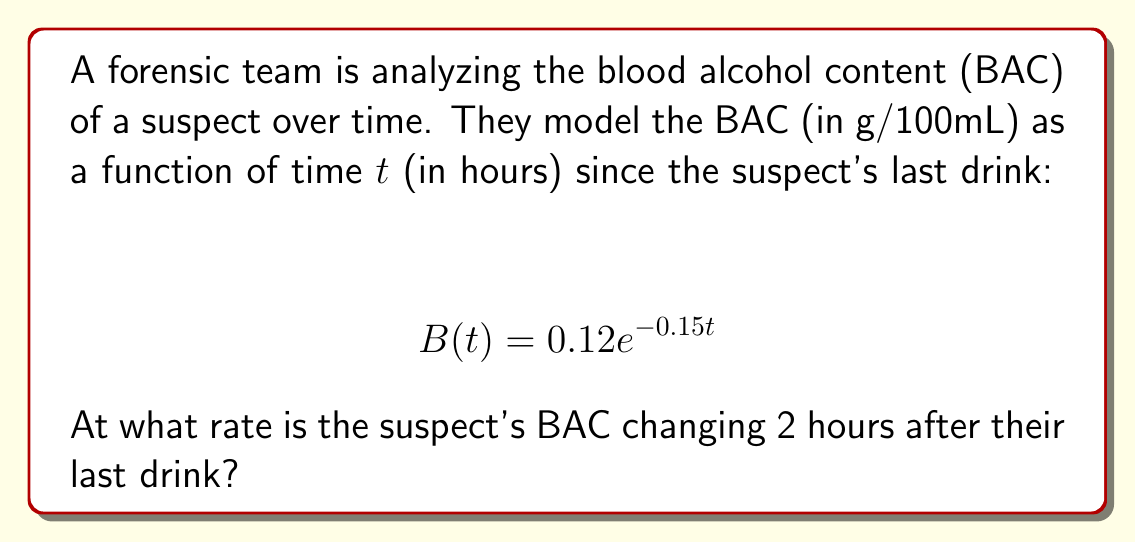What is the answer to this math problem? To solve this problem, we need to follow these steps:

1) The rate of change of BAC with respect to time is given by the derivative of B(t).

2) Let's find the derivative of B(t) using the chain rule:

   $$ \frac{dB}{dt} = 0.12 \cdot (-0.15) \cdot e^{-0.15t} = -0.018e^{-0.15t} $$

3) This derivative represents the instantaneous rate of change of BAC at any time t.

4) To find the rate of change at t = 2 hours, we substitute t = 2 into our derivative function:

   $$ \left.\frac{dB}{dt}\right|_{t=2} = -0.018e^{-0.15(2)} $$

5) Let's calculate this value:
   
   $$ -0.018e^{-0.3} \approx -0.013356 $$

6) The negative value indicates that the BAC is decreasing.

Therefore, 2 hours after the last drink, the suspect's BAC is decreasing at a rate of approximately 0.013356 g/100mL per hour.
Answer: $-0.013356$ g/100mL per hour 